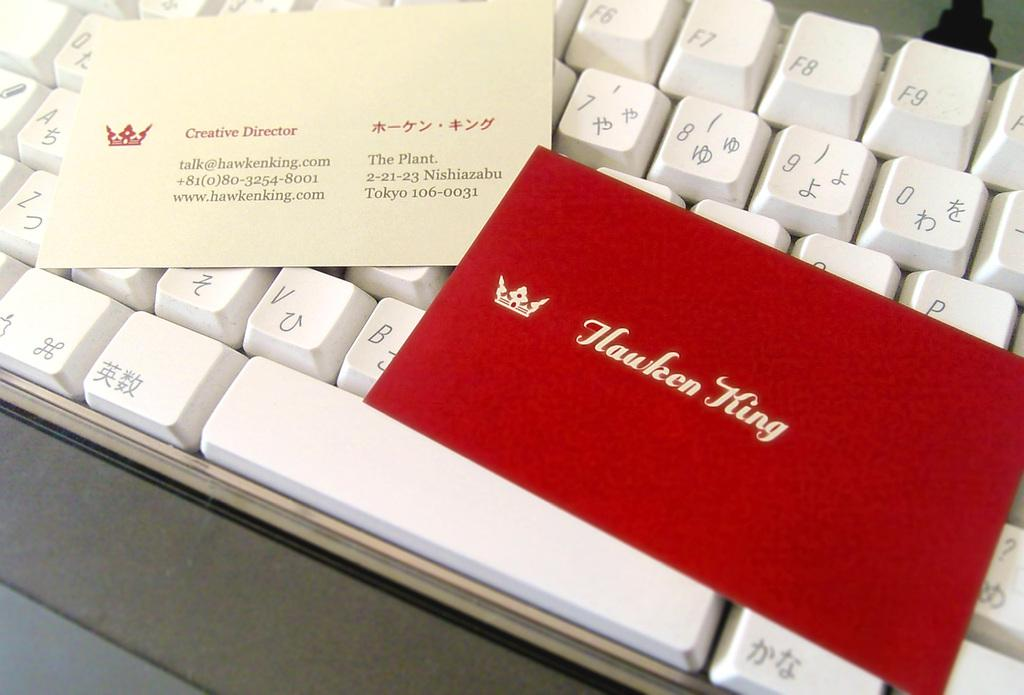<image>
Relay a brief, clear account of the picture shown. red lettered business card for Hawken King laying on a white computer keyboard 